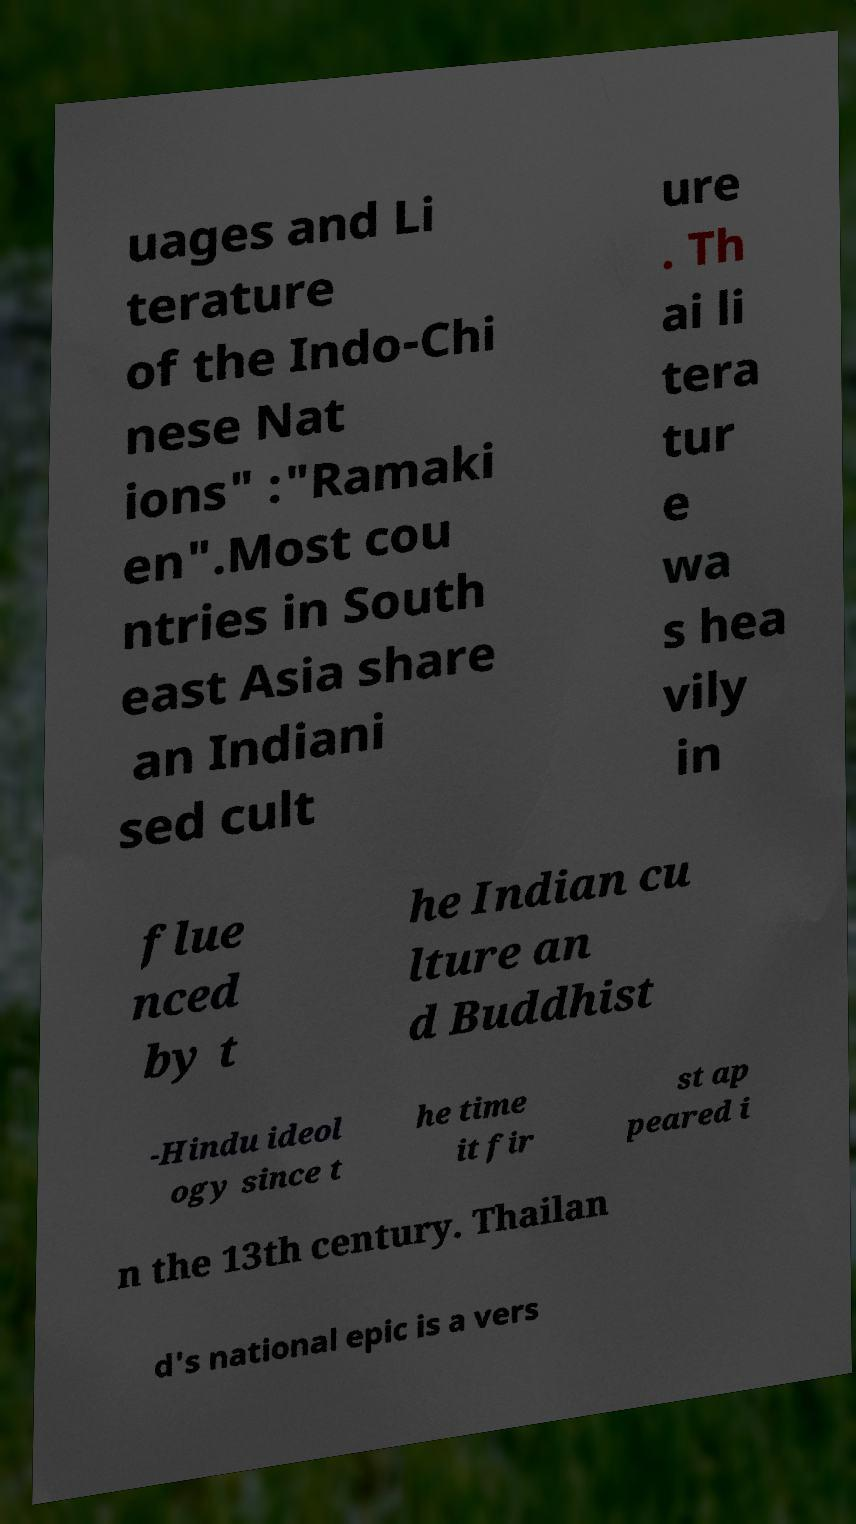What messages or text are displayed in this image? I need them in a readable, typed format. uages and Li terature of the Indo-Chi nese Nat ions" :"Ramaki en".Most cou ntries in South east Asia share an Indiani sed cult ure . Th ai li tera tur e wa s hea vily in flue nced by t he Indian cu lture an d Buddhist -Hindu ideol ogy since t he time it fir st ap peared i n the 13th century. Thailan d's national epic is a vers 